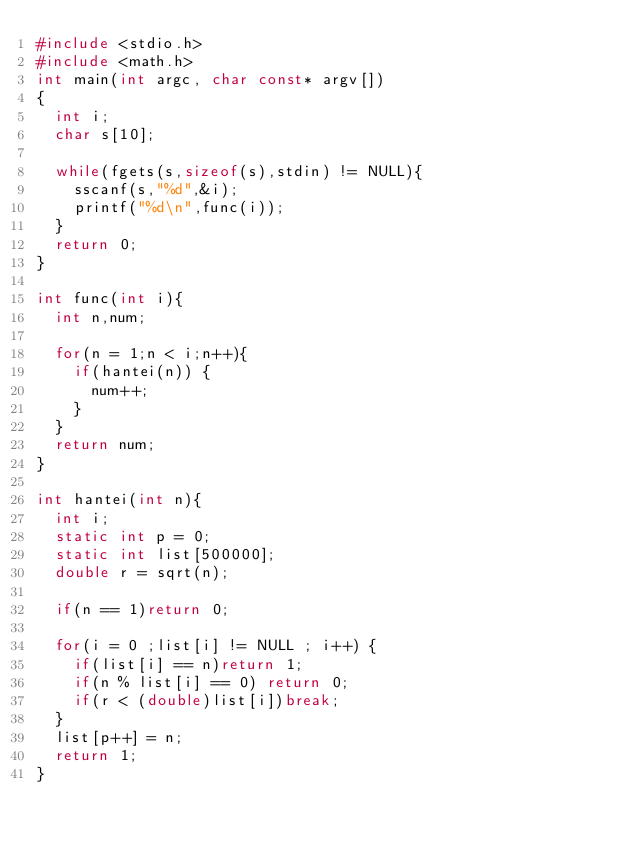<code> <loc_0><loc_0><loc_500><loc_500><_C_>#include <stdio.h>
#include <math.h>
int main(int argc, char const* argv[])
{
	int i;
	char s[10];

	while(fgets(s,sizeof(s),stdin) != NULL){
		sscanf(s,"%d",&i);
		printf("%d\n",func(i));
	}
	return 0;
}

int func(int i){
	int n,num;

	for(n = 1;n < i;n++){
		if(hantei(n)) {
			num++;
		}
	}
	return num;
}

int hantei(int n){
	int i;
	static int p = 0;
	static int list[500000];
	double r = sqrt(n);

	if(n == 1)return 0;

	for(i = 0 ;list[i] != NULL ; i++) {
		if(list[i] == n)return 1;
		if(n % list[i] == 0) return 0;
		if(r < (double)list[i])break;
	}
	list[p++] = n;
	return 1;
}</code> 